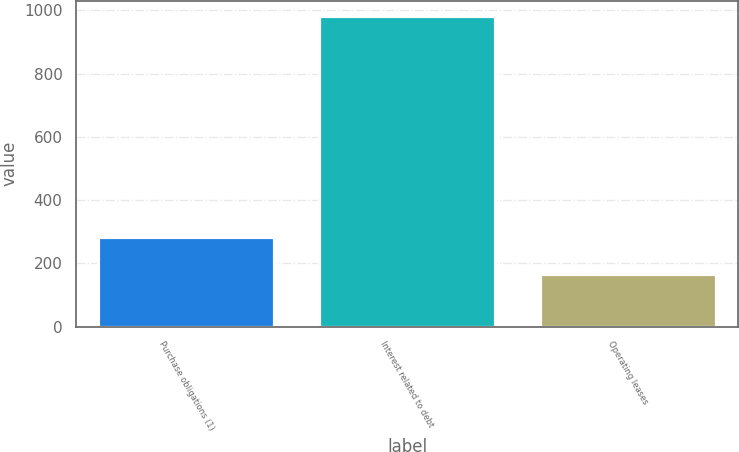Convert chart. <chart><loc_0><loc_0><loc_500><loc_500><bar_chart><fcel>Purchase obligations (1)<fcel>Interest related to debt<fcel>Operating leases<nl><fcel>282<fcel>981<fcel>166<nl></chart> 